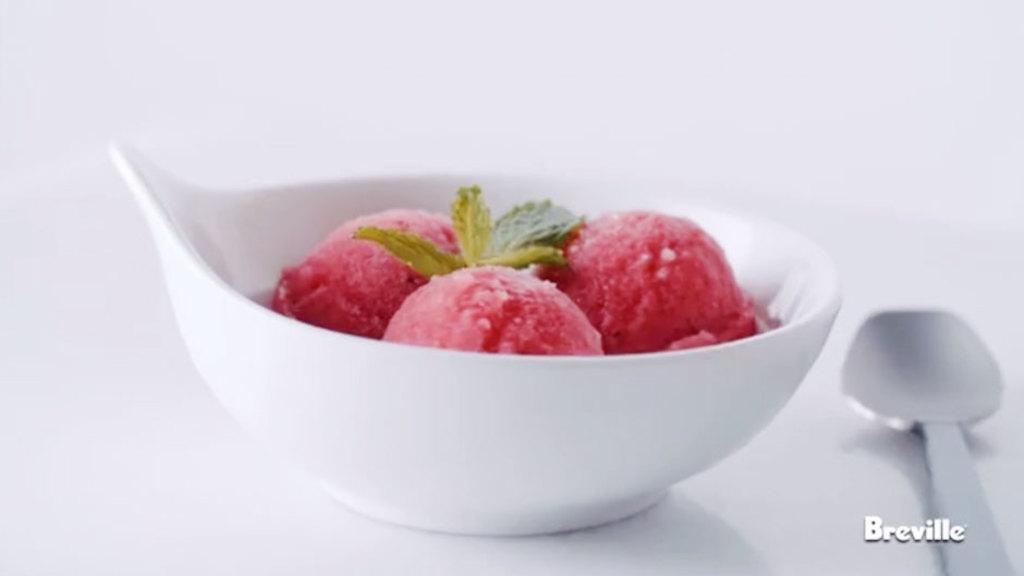Please provide a concise description of this image. Here in this picture we can see a bowl which is filled with ice cream, present on a table and we can also see some mint leaves on it and beside that we can see a spoon present. 